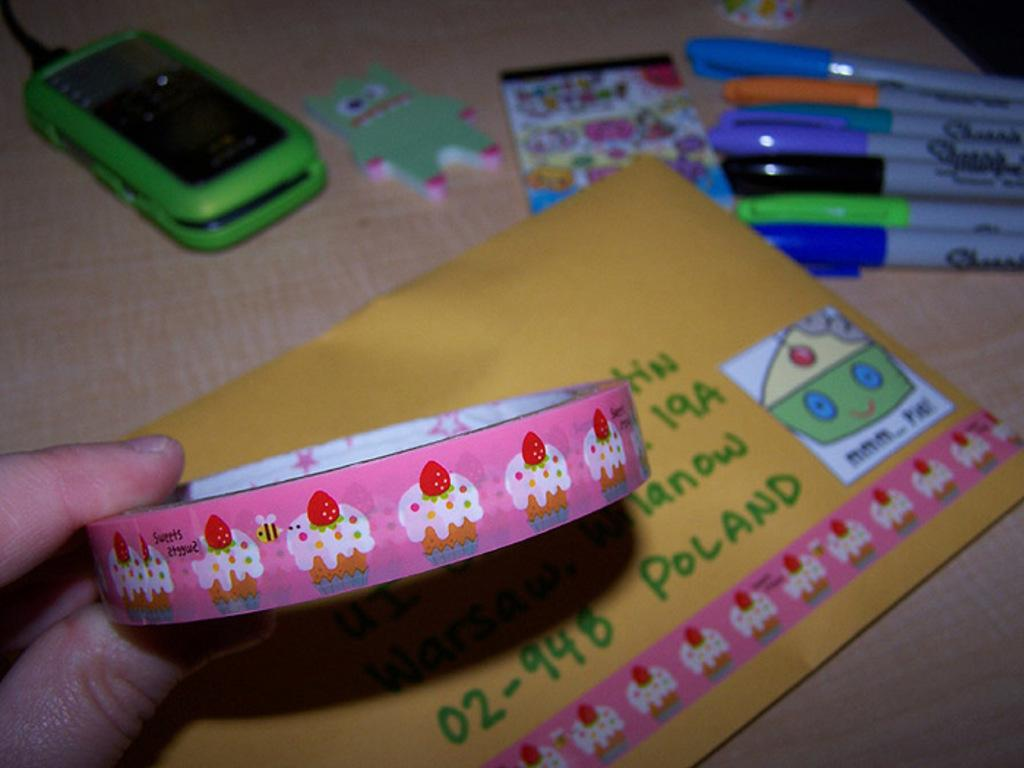Provide a one-sentence caption for the provided image. A hand holds pink tape with cupcakes on it over an envelope addressed to Poland on which a strip of the tape has been placed. 